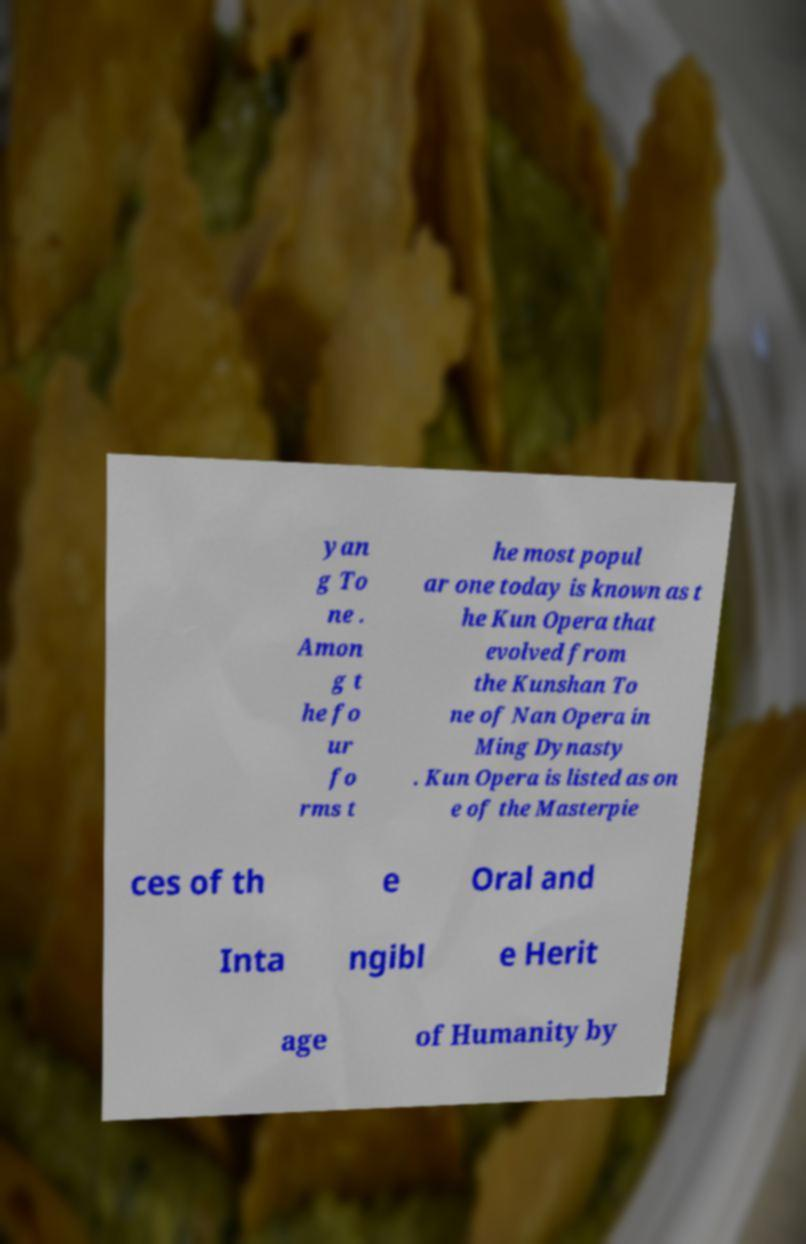Could you extract and type out the text from this image? yan g To ne . Amon g t he fo ur fo rms t he most popul ar one today is known as t he Kun Opera that evolved from the Kunshan To ne of Nan Opera in Ming Dynasty . Kun Opera is listed as on e of the Masterpie ces of th e Oral and Inta ngibl e Herit age of Humanity by 